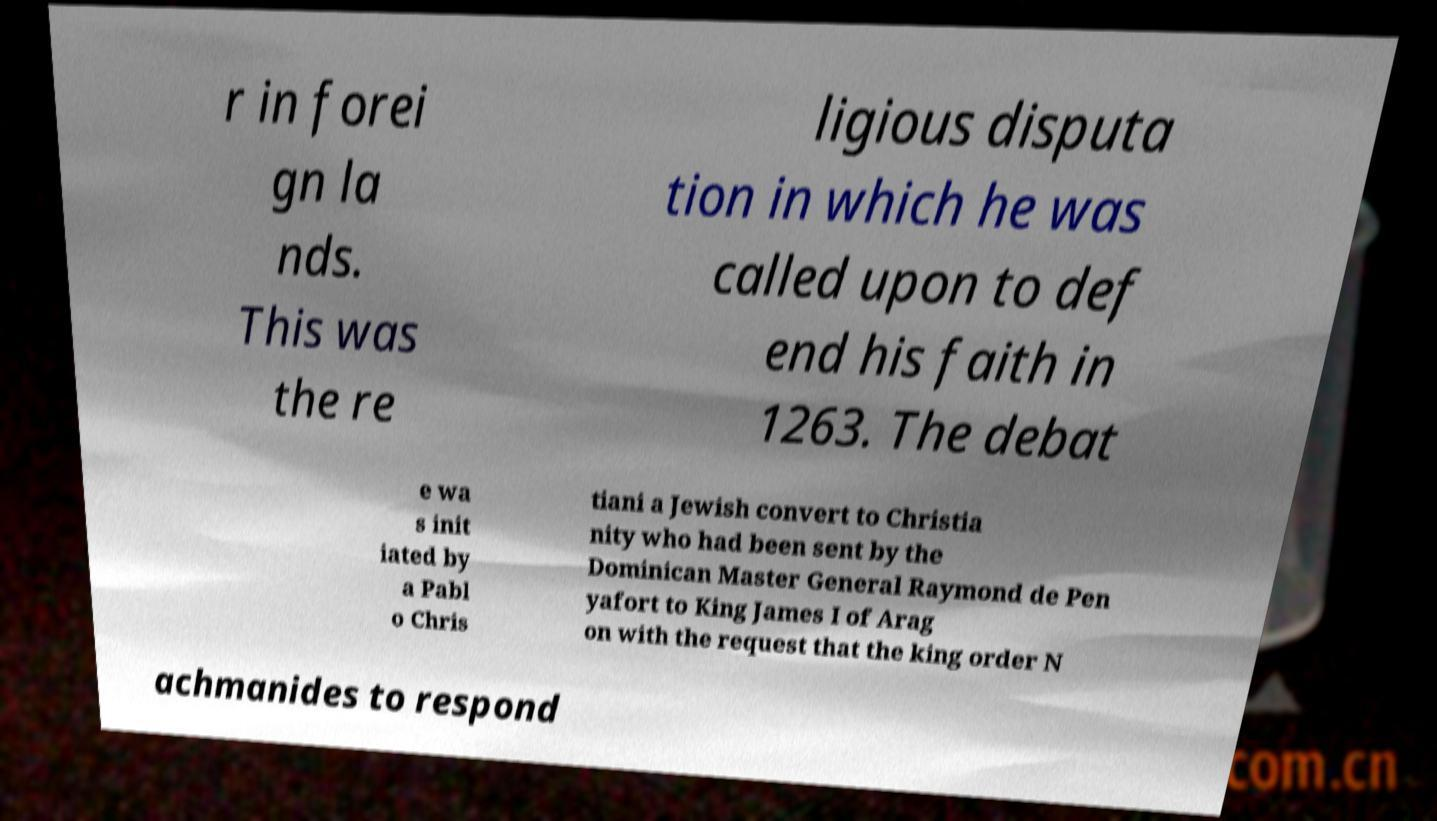Please identify and transcribe the text found in this image. r in forei gn la nds. This was the re ligious disputa tion in which he was called upon to def end his faith in 1263. The debat e wa s init iated by a Pabl o Chris tiani a Jewish convert to Christia nity who had been sent by the Dominican Master General Raymond de Pen yafort to King James I of Arag on with the request that the king order N achmanides to respond 